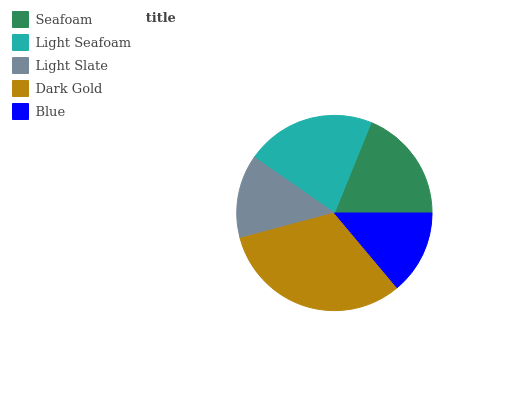Is Light Slate the minimum?
Answer yes or no. Yes. Is Dark Gold the maximum?
Answer yes or no. Yes. Is Light Seafoam the minimum?
Answer yes or no. No. Is Light Seafoam the maximum?
Answer yes or no. No. Is Light Seafoam greater than Seafoam?
Answer yes or no. Yes. Is Seafoam less than Light Seafoam?
Answer yes or no. Yes. Is Seafoam greater than Light Seafoam?
Answer yes or no. No. Is Light Seafoam less than Seafoam?
Answer yes or no. No. Is Seafoam the high median?
Answer yes or no. Yes. Is Seafoam the low median?
Answer yes or no. Yes. Is Light Slate the high median?
Answer yes or no. No. Is Light Slate the low median?
Answer yes or no. No. 